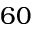<formula> <loc_0><loc_0><loc_500><loc_500>6 0</formula> 